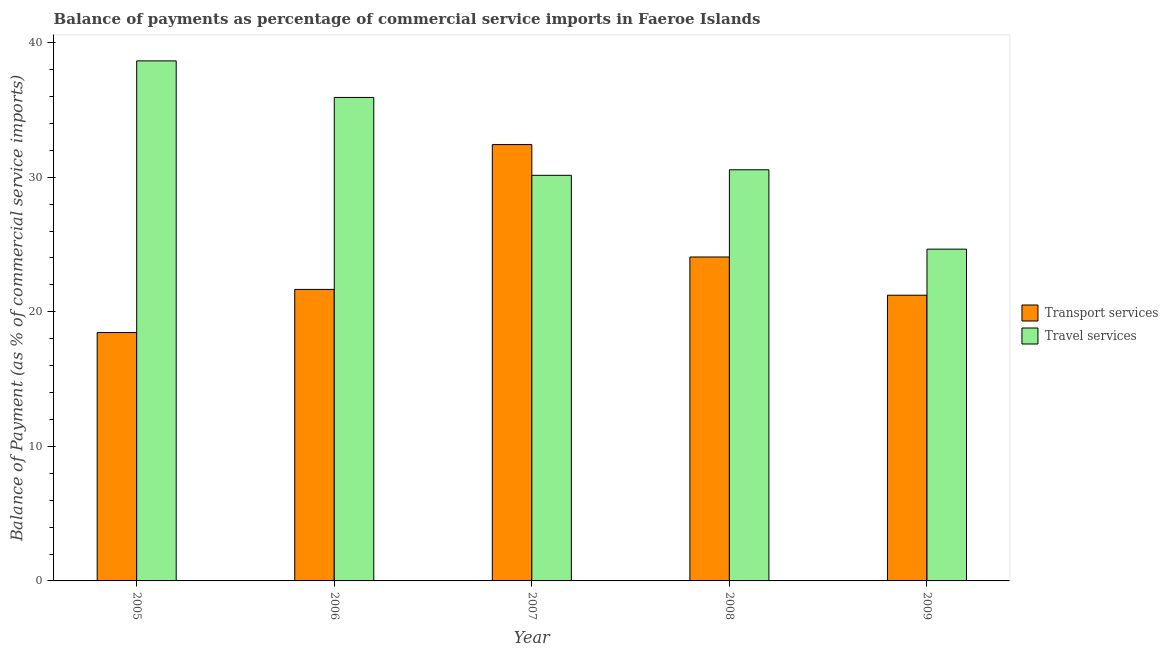How many different coloured bars are there?
Provide a succinct answer. 2. How many bars are there on the 2nd tick from the left?
Your answer should be very brief. 2. How many bars are there on the 3rd tick from the right?
Ensure brevity in your answer.  2. What is the label of the 1st group of bars from the left?
Your response must be concise. 2005. What is the balance of payments of transport services in 2006?
Keep it short and to the point. 21.66. Across all years, what is the maximum balance of payments of travel services?
Ensure brevity in your answer.  38.65. Across all years, what is the minimum balance of payments of transport services?
Provide a short and direct response. 18.46. In which year was the balance of payments of travel services maximum?
Ensure brevity in your answer.  2005. In which year was the balance of payments of transport services minimum?
Your answer should be compact. 2005. What is the total balance of payments of transport services in the graph?
Provide a succinct answer. 117.85. What is the difference between the balance of payments of travel services in 2006 and that in 2008?
Your response must be concise. 5.37. What is the difference between the balance of payments of travel services in 2006 and the balance of payments of transport services in 2007?
Ensure brevity in your answer.  5.79. What is the average balance of payments of transport services per year?
Your answer should be very brief. 23.57. In the year 2009, what is the difference between the balance of payments of transport services and balance of payments of travel services?
Ensure brevity in your answer.  0. In how many years, is the balance of payments of travel services greater than 4 %?
Make the answer very short. 5. What is the ratio of the balance of payments of travel services in 2005 to that in 2009?
Make the answer very short. 1.57. Is the difference between the balance of payments of transport services in 2007 and 2009 greater than the difference between the balance of payments of travel services in 2007 and 2009?
Offer a terse response. No. What is the difference between the highest and the second highest balance of payments of travel services?
Your answer should be very brief. 2.72. What is the difference between the highest and the lowest balance of payments of transport services?
Your answer should be very brief. 13.97. In how many years, is the balance of payments of travel services greater than the average balance of payments of travel services taken over all years?
Your response must be concise. 2. What does the 2nd bar from the left in 2009 represents?
Make the answer very short. Travel services. What does the 2nd bar from the right in 2009 represents?
Your answer should be compact. Transport services. What is the difference between two consecutive major ticks on the Y-axis?
Your answer should be very brief. 10. Does the graph contain grids?
Offer a very short reply. No. Where does the legend appear in the graph?
Provide a succinct answer. Center right. How are the legend labels stacked?
Your response must be concise. Vertical. What is the title of the graph?
Keep it short and to the point. Balance of payments as percentage of commercial service imports in Faeroe Islands. What is the label or title of the Y-axis?
Ensure brevity in your answer.  Balance of Payment (as % of commercial service imports). What is the Balance of Payment (as % of commercial service imports) in Transport services in 2005?
Your answer should be compact. 18.46. What is the Balance of Payment (as % of commercial service imports) in Travel services in 2005?
Ensure brevity in your answer.  38.65. What is the Balance of Payment (as % of commercial service imports) in Transport services in 2006?
Provide a succinct answer. 21.66. What is the Balance of Payment (as % of commercial service imports) of Travel services in 2006?
Provide a short and direct response. 35.93. What is the Balance of Payment (as % of commercial service imports) in Transport services in 2007?
Give a very brief answer. 32.43. What is the Balance of Payment (as % of commercial service imports) in Travel services in 2007?
Your answer should be very brief. 30.14. What is the Balance of Payment (as % of commercial service imports) of Transport services in 2008?
Your answer should be compact. 24.07. What is the Balance of Payment (as % of commercial service imports) of Travel services in 2008?
Offer a very short reply. 30.55. What is the Balance of Payment (as % of commercial service imports) in Transport services in 2009?
Give a very brief answer. 21.23. What is the Balance of Payment (as % of commercial service imports) of Travel services in 2009?
Provide a succinct answer. 24.65. Across all years, what is the maximum Balance of Payment (as % of commercial service imports) of Transport services?
Ensure brevity in your answer.  32.43. Across all years, what is the maximum Balance of Payment (as % of commercial service imports) of Travel services?
Ensure brevity in your answer.  38.65. Across all years, what is the minimum Balance of Payment (as % of commercial service imports) in Transport services?
Your response must be concise. 18.46. Across all years, what is the minimum Balance of Payment (as % of commercial service imports) in Travel services?
Ensure brevity in your answer.  24.65. What is the total Balance of Payment (as % of commercial service imports) in Transport services in the graph?
Offer a terse response. 117.85. What is the total Balance of Payment (as % of commercial service imports) of Travel services in the graph?
Your answer should be very brief. 159.92. What is the difference between the Balance of Payment (as % of commercial service imports) in Transport services in 2005 and that in 2006?
Give a very brief answer. -3.21. What is the difference between the Balance of Payment (as % of commercial service imports) of Travel services in 2005 and that in 2006?
Your answer should be very brief. 2.72. What is the difference between the Balance of Payment (as % of commercial service imports) in Transport services in 2005 and that in 2007?
Offer a terse response. -13.97. What is the difference between the Balance of Payment (as % of commercial service imports) of Travel services in 2005 and that in 2007?
Ensure brevity in your answer.  8.5. What is the difference between the Balance of Payment (as % of commercial service imports) of Transport services in 2005 and that in 2008?
Your response must be concise. -5.62. What is the difference between the Balance of Payment (as % of commercial service imports) of Travel services in 2005 and that in 2008?
Your answer should be very brief. 8.09. What is the difference between the Balance of Payment (as % of commercial service imports) of Transport services in 2005 and that in 2009?
Your answer should be compact. -2.77. What is the difference between the Balance of Payment (as % of commercial service imports) of Travel services in 2005 and that in 2009?
Your answer should be compact. 13.99. What is the difference between the Balance of Payment (as % of commercial service imports) in Transport services in 2006 and that in 2007?
Make the answer very short. -10.76. What is the difference between the Balance of Payment (as % of commercial service imports) in Travel services in 2006 and that in 2007?
Keep it short and to the point. 5.79. What is the difference between the Balance of Payment (as % of commercial service imports) of Transport services in 2006 and that in 2008?
Provide a succinct answer. -2.41. What is the difference between the Balance of Payment (as % of commercial service imports) in Travel services in 2006 and that in 2008?
Your answer should be compact. 5.37. What is the difference between the Balance of Payment (as % of commercial service imports) in Transport services in 2006 and that in 2009?
Keep it short and to the point. 0.43. What is the difference between the Balance of Payment (as % of commercial service imports) in Travel services in 2006 and that in 2009?
Provide a succinct answer. 11.27. What is the difference between the Balance of Payment (as % of commercial service imports) of Transport services in 2007 and that in 2008?
Your answer should be very brief. 8.35. What is the difference between the Balance of Payment (as % of commercial service imports) of Travel services in 2007 and that in 2008?
Your answer should be compact. -0.41. What is the difference between the Balance of Payment (as % of commercial service imports) of Transport services in 2007 and that in 2009?
Provide a short and direct response. 11.19. What is the difference between the Balance of Payment (as % of commercial service imports) of Travel services in 2007 and that in 2009?
Offer a very short reply. 5.49. What is the difference between the Balance of Payment (as % of commercial service imports) in Transport services in 2008 and that in 2009?
Your answer should be very brief. 2.84. What is the difference between the Balance of Payment (as % of commercial service imports) in Travel services in 2008 and that in 2009?
Make the answer very short. 5.9. What is the difference between the Balance of Payment (as % of commercial service imports) in Transport services in 2005 and the Balance of Payment (as % of commercial service imports) in Travel services in 2006?
Offer a very short reply. -17.47. What is the difference between the Balance of Payment (as % of commercial service imports) of Transport services in 2005 and the Balance of Payment (as % of commercial service imports) of Travel services in 2007?
Make the answer very short. -11.68. What is the difference between the Balance of Payment (as % of commercial service imports) of Transport services in 2005 and the Balance of Payment (as % of commercial service imports) of Travel services in 2008?
Keep it short and to the point. -12.1. What is the difference between the Balance of Payment (as % of commercial service imports) in Transport services in 2005 and the Balance of Payment (as % of commercial service imports) in Travel services in 2009?
Ensure brevity in your answer.  -6.2. What is the difference between the Balance of Payment (as % of commercial service imports) in Transport services in 2006 and the Balance of Payment (as % of commercial service imports) in Travel services in 2007?
Keep it short and to the point. -8.48. What is the difference between the Balance of Payment (as % of commercial service imports) in Transport services in 2006 and the Balance of Payment (as % of commercial service imports) in Travel services in 2008?
Give a very brief answer. -8.89. What is the difference between the Balance of Payment (as % of commercial service imports) of Transport services in 2006 and the Balance of Payment (as % of commercial service imports) of Travel services in 2009?
Offer a very short reply. -2.99. What is the difference between the Balance of Payment (as % of commercial service imports) of Transport services in 2007 and the Balance of Payment (as % of commercial service imports) of Travel services in 2008?
Your response must be concise. 1.87. What is the difference between the Balance of Payment (as % of commercial service imports) of Transport services in 2007 and the Balance of Payment (as % of commercial service imports) of Travel services in 2009?
Keep it short and to the point. 7.77. What is the difference between the Balance of Payment (as % of commercial service imports) of Transport services in 2008 and the Balance of Payment (as % of commercial service imports) of Travel services in 2009?
Keep it short and to the point. -0.58. What is the average Balance of Payment (as % of commercial service imports) of Transport services per year?
Provide a succinct answer. 23.57. What is the average Balance of Payment (as % of commercial service imports) of Travel services per year?
Provide a short and direct response. 31.98. In the year 2005, what is the difference between the Balance of Payment (as % of commercial service imports) in Transport services and Balance of Payment (as % of commercial service imports) in Travel services?
Give a very brief answer. -20.19. In the year 2006, what is the difference between the Balance of Payment (as % of commercial service imports) of Transport services and Balance of Payment (as % of commercial service imports) of Travel services?
Your response must be concise. -14.27. In the year 2007, what is the difference between the Balance of Payment (as % of commercial service imports) of Transport services and Balance of Payment (as % of commercial service imports) of Travel services?
Provide a succinct answer. 2.29. In the year 2008, what is the difference between the Balance of Payment (as % of commercial service imports) of Transport services and Balance of Payment (as % of commercial service imports) of Travel services?
Offer a terse response. -6.48. In the year 2009, what is the difference between the Balance of Payment (as % of commercial service imports) in Transport services and Balance of Payment (as % of commercial service imports) in Travel services?
Ensure brevity in your answer.  -3.42. What is the ratio of the Balance of Payment (as % of commercial service imports) of Transport services in 2005 to that in 2006?
Keep it short and to the point. 0.85. What is the ratio of the Balance of Payment (as % of commercial service imports) of Travel services in 2005 to that in 2006?
Provide a succinct answer. 1.08. What is the ratio of the Balance of Payment (as % of commercial service imports) in Transport services in 2005 to that in 2007?
Your answer should be compact. 0.57. What is the ratio of the Balance of Payment (as % of commercial service imports) of Travel services in 2005 to that in 2007?
Make the answer very short. 1.28. What is the ratio of the Balance of Payment (as % of commercial service imports) of Transport services in 2005 to that in 2008?
Give a very brief answer. 0.77. What is the ratio of the Balance of Payment (as % of commercial service imports) in Travel services in 2005 to that in 2008?
Offer a very short reply. 1.26. What is the ratio of the Balance of Payment (as % of commercial service imports) in Transport services in 2005 to that in 2009?
Provide a succinct answer. 0.87. What is the ratio of the Balance of Payment (as % of commercial service imports) of Travel services in 2005 to that in 2009?
Make the answer very short. 1.57. What is the ratio of the Balance of Payment (as % of commercial service imports) of Transport services in 2006 to that in 2007?
Offer a very short reply. 0.67. What is the ratio of the Balance of Payment (as % of commercial service imports) of Travel services in 2006 to that in 2007?
Keep it short and to the point. 1.19. What is the ratio of the Balance of Payment (as % of commercial service imports) in Transport services in 2006 to that in 2008?
Ensure brevity in your answer.  0.9. What is the ratio of the Balance of Payment (as % of commercial service imports) of Travel services in 2006 to that in 2008?
Provide a short and direct response. 1.18. What is the ratio of the Balance of Payment (as % of commercial service imports) in Transport services in 2006 to that in 2009?
Provide a short and direct response. 1.02. What is the ratio of the Balance of Payment (as % of commercial service imports) in Travel services in 2006 to that in 2009?
Make the answer very short. 1.46. What is the ratio of the Balance of Payment (as % of commercial service imports) in Transport services in 2007 to that in 2008?
Offer a very short reply. 1.35. What is the ratio of the Balance of Payment (as % of commercial service imports) of Travel services in 2007 to that in 2008?
Provide a succinct answer. 0.99. What is the ratio of the Balance of Payment (as % of commercial service imports) in Transport services in 2007 to that in 2009?
Ensure brevity in your answer.  1.53. What is the ratio of the Balance of Payment (as % of commercial service imports) of Travel services in 2007 to that in 2009?
Offer a terse response. 1.22. What is the ratio of the Balance of Payment (as % of commercial service imports) in Transport services in 2008 to that in 2009?
Make the answer very short. 1.13. What is the ratio of the Balance of Payment (as % of commercial service imports) of Travel services in 2008 to that in 2009?
Your answer should be compact. 1.24. What is the difference between the highest and the second highest Balance of Payment (as % of commercial service imports) in Transport services?
Ensure brevity in your answer.  8.35. What is the difference between the highest and the second highest Balance of Payment (as % of commercial service imports) in Travel services?
Your answer should be very brief. 2.72. What is the difference between the highest and the lowest Balance of Payment (as % of commercial service imports) of Transport services?
Ensure brevity in your answer.  13.97. What is the difference between the highest and the lowest Balance of Payment (as % of commercial service imports) of Travel services?
Provide a short and direct response. 13.99. 